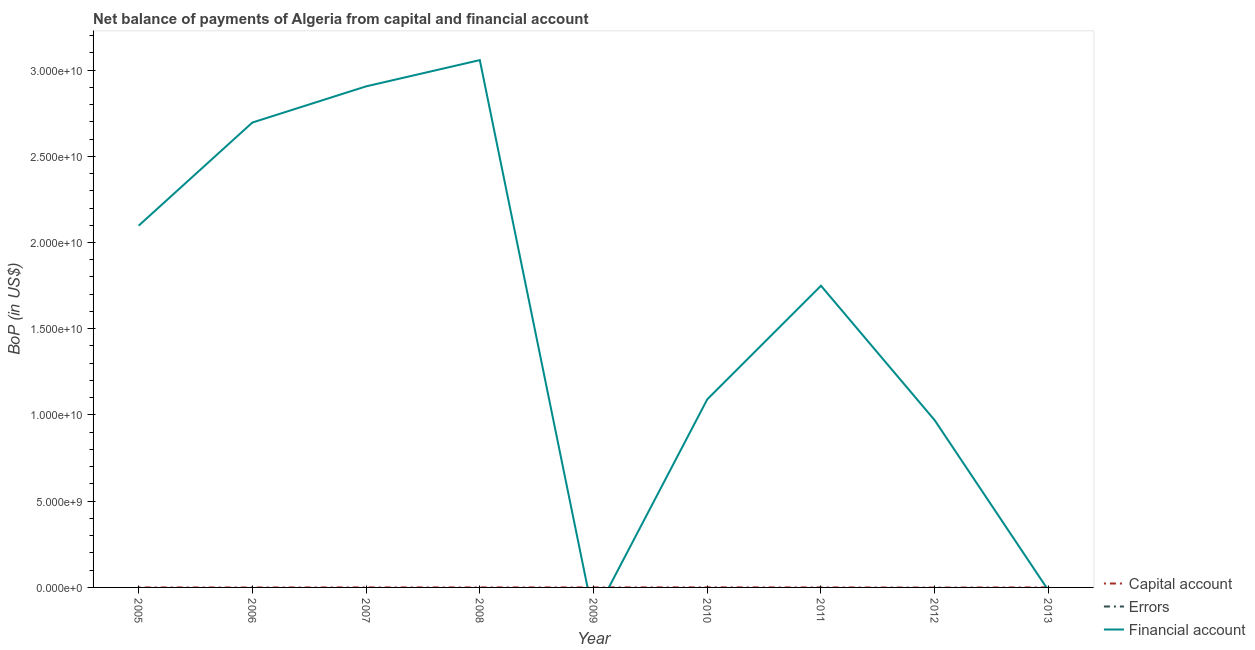Does the line corresponding to amount of financial account intersect with the line corresponding to amount of net capital account?
Make the answer very short. Yes. Is the number of lines equal to the number of legend labels?
Your answer should be very brief. No. What is the amount of financial account in 2010?
Keep it short and to the point. 1.09e+1. Across all years, what is the maximum amount of net capital account?
Provide a succinct answer. 3.82e+06. Across all years, what is the minimum amount of net capital account?
Your response must be concise. 0. What is the difference between the amount of financial account in 2010 and that in 2011?
Your answer should be very brief. -6.59e+09. What is the difference between the amount of errors in 2008 and the amount of financial account in 2011?
Make the answer very short. -1.75e+1. What is the average amount of net capital account per year?
Ensure brevity in your answer.  4.50e+05. In the year 2010, what is the difference between the amount of net capital account and amount of financial account?
Give a very brief answer. -1.09e+1. What is the difference between the highest and the second highest amount of financial account?
Give a very brief answer. 1.52e+09. What is the difference between the highest and the lowest amount of financial account?
Give a very brief answer. 3.06e+1. In how many years, is the amount of financial account greater than the average amount of financial account taken over all years?
Offer a terse response. 5. Is the sum of the amount of financial account in 2005 and 2012 greater than the maximum amount of net capital account across all years?
Provide a short and direct response. Yes. Does the amount of financial account monotonically increase over the years?
Give a very brief answer. No. Is the amount of net capital account strictly greater than the amount of financial account over the years?
Make the answer very short. No. Is the amount of financial account strictly less than the amount of errors over the years?
Keep it short and to the point. No. How many years are there in the graph?
Provide a short and direct response. 9. Are the values on the major ticks of Y-axis written in scientific E-notation?
Provide a short and direct response. Yes. Does the graph contain any zero values?
Offer a very short reply. Yes. Does the graph contain grids?
Your answer should be very brief. No. Where does the legend appear in the graph?
Keep it short and to the point. Bottom right. How many legend labels are there?
Make the answer very short. 3. What is the title of the graph?
Your answer should be compact. Net balance of payments of Algeria from capital and financial account. Does "Taxes on income" appear as one of the legend labels in the graph?
Offer a very short reply. No. What is the label or title of the Y-axis?
Keep it short and to the point. BoP (in US$). What is the BoP (in US$) in Capital account in 2005?
Offer a very short reply. 0. What is the BoP (in US$) of Financial account in 2005?
Your response must be concise. 2.10e+1. What is the BoP (in US$) of Errors in 2006?
Offer a very short reply. 0. What is the BoP (in US$) of Financial account in 2006?
Offer a terse response. 2.70e+1. What is the BoP (in US$) of Errors in 2007?
Give a very brief answer. 0. What is the BoP (in US$) of Financial account in 2007?
Make the answer very short. 2.91e+1. What is the BoP (in US$) in Capital account in 2008?
Your response must be concise. 0. What is the BoP (in US$) in Financial account in 2008?
Make the answer very short. 3.06e+1. What is the BoP (in US$) of Capital account in 2010?
Make the answer very short. 3.82e+06. What is the BoP (in US$) of Financial account in 2010?
Give a very brief answer. 1.09e+1. What is the BoP (in US$) of Capital account in 2011?
Your answer should be compact. 0. What is the BoP (in US$) of Financial account in 2011?
Offer a terse response. 1.75e+1. What is the BoP (in US$) of Errors in 2012?
Offer a very short reply. 0. What is the BoP (in US$) in Financial account in 2012?
Offer a terse response. 9.69e+09. What is the BoP (in US$) in Capital account in 2013?
Ensure brevity in your answer.  2.24e+05. Across all years, what is the maximum BoP (in US$) in Capital account?
Provide a short and direct response. 3.82e+06. Across all years, what is the maximum BoP (in US$) of Financial account?
Provide a succinct answer. 3.06e+1. Across all years, what is the minimum BoP (in US$) of Capital account?
Make the answer very short. 0. Across all years, what is the minimum BoP (in US$) in Financial account?
Your answer should be compact. 0. What is the total BoP (in US$) in Capital account in the graph?
Give a very brief answer. 4.05e+06. What is the total BoP (in US$) of Errors in the graph?
Give a very brief answer. 0. What is the total BoP (in US$) of Financial account in the graph?
Provide a short and direct response. 1.46e+11. What is the difference between the BoP (in US$) of Financial account in 2005 and that in 2006?
Keep it short and to the point. -5.98e+09. What is the difference between the BoP (in US$) of Financial account in 2005 and that in 2007?
Your response must be concise. -8.08e+09. What is the difference between the BoP (in US$) of Financial account in 2005 and that in 2008?
Offer a very short reply. -9.60e+09. What is the difference between the BoP (in US$) of Financial account in 2005 and that in 2010?
Offer a very short reply. 1.01e+1. What is the difference between the BoP (in US$) in Financial account in 2005 and that in 2011?
Offer a very short reply. 3.48e+09. What is the difference between the BoP (in US$) in Financial account in 2005 and that in 2012?
Give a very brief answer. 1.13e+1. What is the difference between the BoP (in US$) in Financial account in 2006 and that in 2007?
Your answer should be compact. -2.10e+09. What is the difference between the BoP (in US$) in Financial account in 2006 and that in 2008?
Give a very brief answer. -3.62e+09. What is the difference between the BoP (in US$) in Financial account in 2006 and that in 2010?
Provide a succinct answer. 1.60e+1. What is the difference between the BoP (in US$) in Financial account in 2006 and that in 2011?
Provide a short and direct response. 9.46e+09. What is the difference between the BoP (in US$) in Financial account in 2006 and that in 2012?
Your answer should be compact. 1.73e+1. What is the difference between the BoP (in US$) of Financial account in 2007 and that in 2008?
Give a very brief answer. -1.52e+09. What is the difference between the BoP (in US$) of Financial account in 2007 and that in 2010?
Make the answer very short. 1.81e+1. What is the difference between the BoP (in US$) of Financial account in 2007 and that in 2011?
Give a very brief answer. 1.16e+1. What is the difference between the BoP (in US$) of Financial account in 2007 and that in 2012?
Ensure brevity in your answer.  1.94e+1. What is the difference between the BoP (in US$) in Financial account in 2008 and that in 2010?
Offer a terse response. 1.97e+1. What is the difference between the BoP (in US$) in Financial account in 2008 and that in 2011?
Your answer should be compact. 1.31e+1. What is the difference between the BoP (in US$) of Financial account in 2008 and that in 2012?
Provide a short and direct response. 2.09e+1. What is the difference between the BoP (in US$) of Financial account in 2010 and that in 2011?
Provide a short and direct response. -6.59e+09. What is the difference between the BoP (in US$) of Financial account in 2010 and that in 2012?
Give a very brief answer. 1.21e+09. What is the difference between the BoP (in US$) of Capital account in 2010 and that in 2013?
Provide a short and direct response. 3.60e+06. What is the difference between the BoP (in US$) in Financial account in 2011 and that in 2012?
Offer a very short reply. 7.80e+09. What is the difference between the BoP (in US$) in Capital account in 2010 and the BoP (in US$) in Financial account in 2011?
Make the answer very short. -1.75e+1. What is the difference between the BoP (in US$) of Capital account in 2010 and the BoP (in US$) of Financial account in 2012?
Offer a terse response. -9.69e+09. What is the average BoP (in US$) of Capital account per year?
Ensure brevity in your answer.  4.50e+05. What is the average BoP (in US$) of Errors per year?
Make the answer very short. 0. What is the average BoP (in US$) in Financial account per year?
Offer a terse response. 1.62e+1. In the year 2010, what is the difference between the BoP (in US$) of Capital account and BoP (in US$) of Financial account?
Ensure brevity in your answer.  -1.09e+1. What is the ratio of the BoP (in US$) of Financial account in 2005 to that in 2006?
Give a very brief answer. 0.78. What is the ratio of the BoP (in US$) in Financial account in 2005 to that in 2007?
Your answer should be very brief. 0.72. What is the ratio of the BoP (in US$) in Financial account in 2005 to that in 2008?
Your answer should be compact. 0.69. What is the ratio of the BoP (in US$) in Financial account in 2005 to that in 2010?
Ensure brevity in your answer.  1.92. What is the ratio of the BoP (in US$) in Financial account in 2005 to that in 2011?
Keep it short and to the point. 1.2. What is the ratio of the BoP (in US$) of Financial account in 2005 to that in 2012?
Provide a short and direct response. 2.16. What is the ratio of the BoP (in US$) of Financial account in 2006 to that in 2007?
Offer a very short reply. 0.93. What is the ratio of the BoP (in US$) of Financial account in 2006 to that in 2008?
Provide a short and direct response. 0.88. What is the ratio of the BoP (in US$) in Financial account in 2006 to that in 2010?
Keep it short and to the point. 2.47. What is the ratio of the BoP (in US$) in Financial account in 2006 to that in 2011?
Offer a terse response. 1.54. What is the ratio of the BoP (in US$) of Financial account in 2006 to that in 2012?
Provide a succinct answer. 2.78. What is the ratio of the BoP (in US$) of Financial account in 2007 to that in 2008?
Your response must be concise. 0.95. What is the ratio of the BoP (in US$) of Financial account in 2007 to that in 2010?
Keep it short and to the point. 2.66. What is the ratio of the BoP (in US$) of Financial account in 2007 to that in 2011?
Keep it short and to the point. 1.66. What is the ratio of the BoP (in US$) in Financial account in 2007 to that in 2012?
Keep it short and to the point. 3. What is the ratio of the BoP (in US$) of Financial account in 2008 to that in 2010?
Provide a succinct answer. 2.8. What is the ratio of the BoP (in US$) in Financial account in 2008 to that in 2011?
Ensure brevity in your answer.  1.75. What is the ratio of the BoP (in US$) in Financial account in 2008 to that in 2012?
Make the answer very short. 3.15. What is the ratio of the BoP (in US$) in Financial account in 2010 to that in 2011?
Provide a succinct answer. 0.62. What is the ratio of the BoP (in US$) in Financial account in 2010 to that in 2012?
Give a very brief answer. 1.13. What is the ratio of the BoP (in US$) in Capital account in 2010 to that in 2013?
Offer a very short reply. 17.08. What is the ratio of the BoP (in US$) in Financial account in 2011 to that in 2012?
Provide a short and direct response. 1.8. What is the difference between the highest and the second highest BoP (in US$) in Financial account?
Offer a terse response. 1.52e+09. What is the difference between the highest and the lowest BoP (in US$) in Capital account?
Ensure brevity in your answer.  3.82e+06. What is the difference between the highest and the lowest BoP (in US$) in Financial account?
Provide a short and direct response. 3.06e+1. 